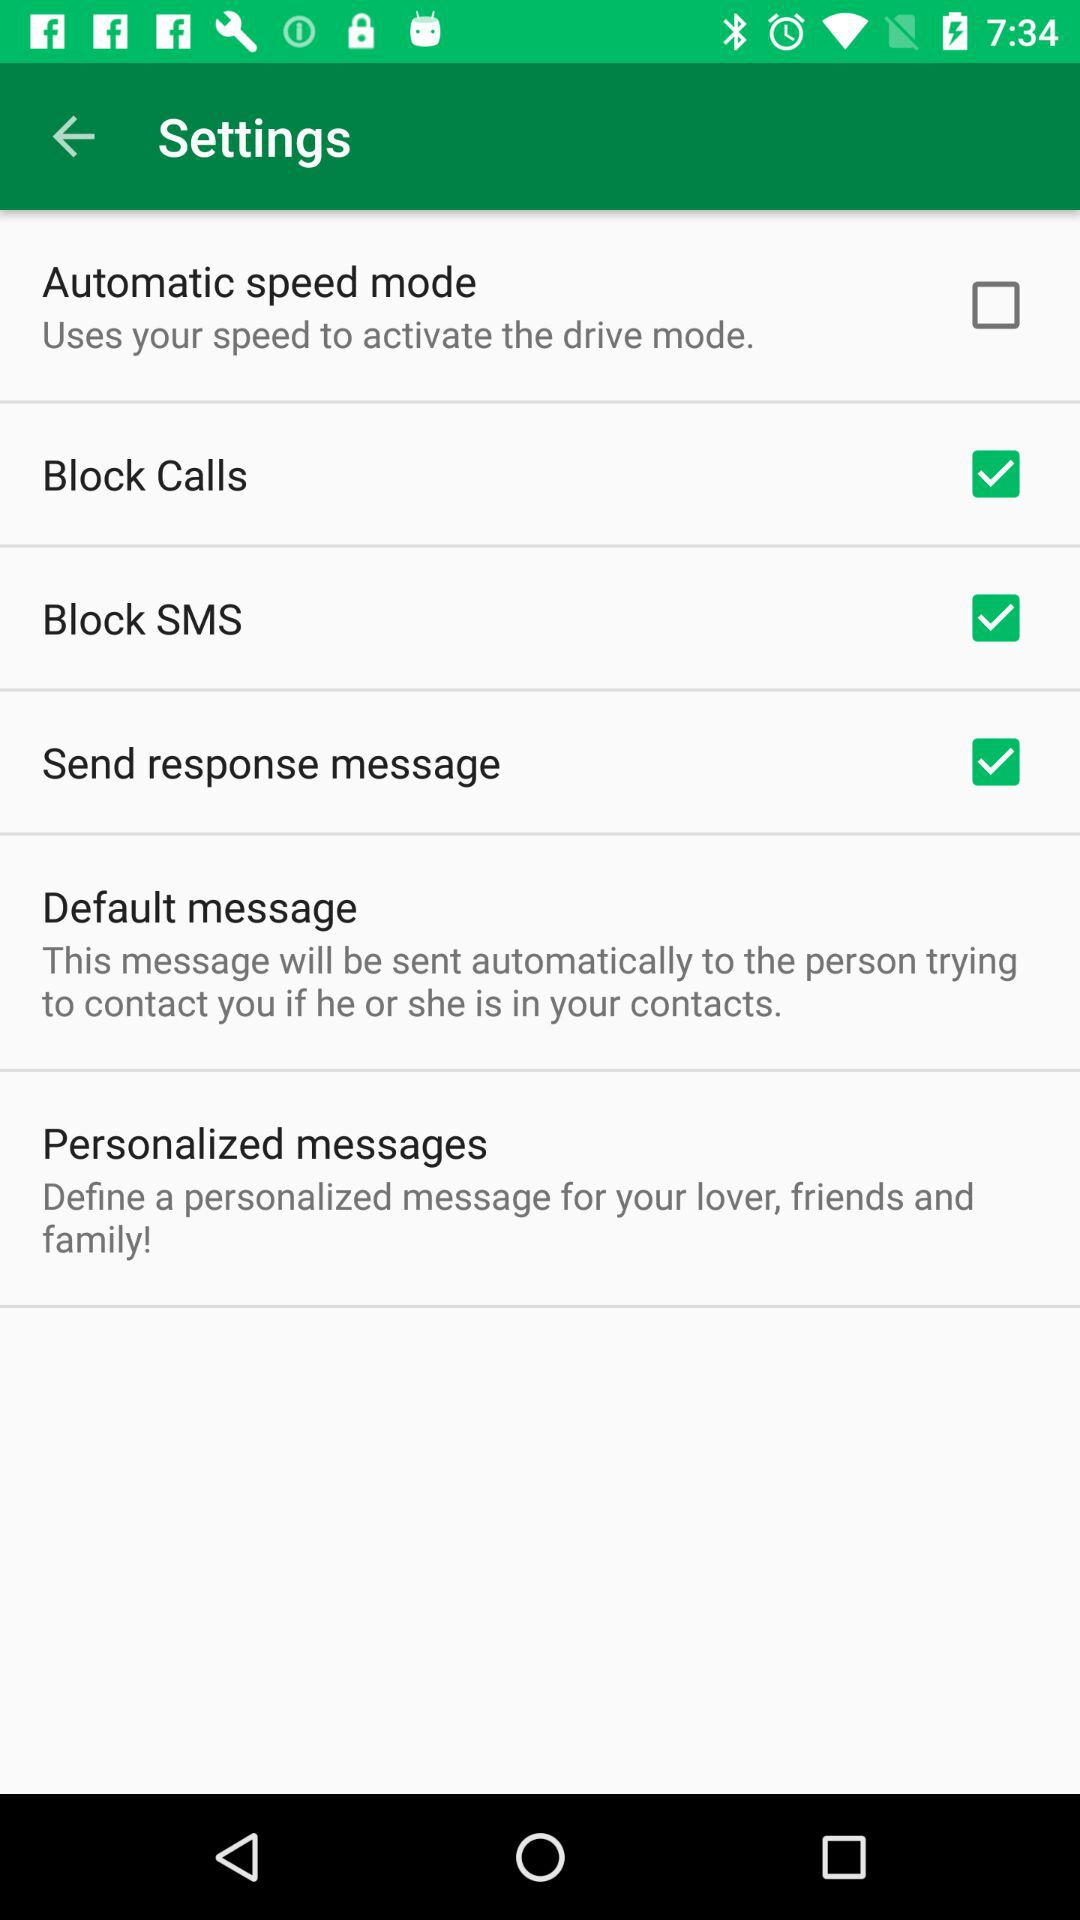What is the status of block SMS? The status is on. 